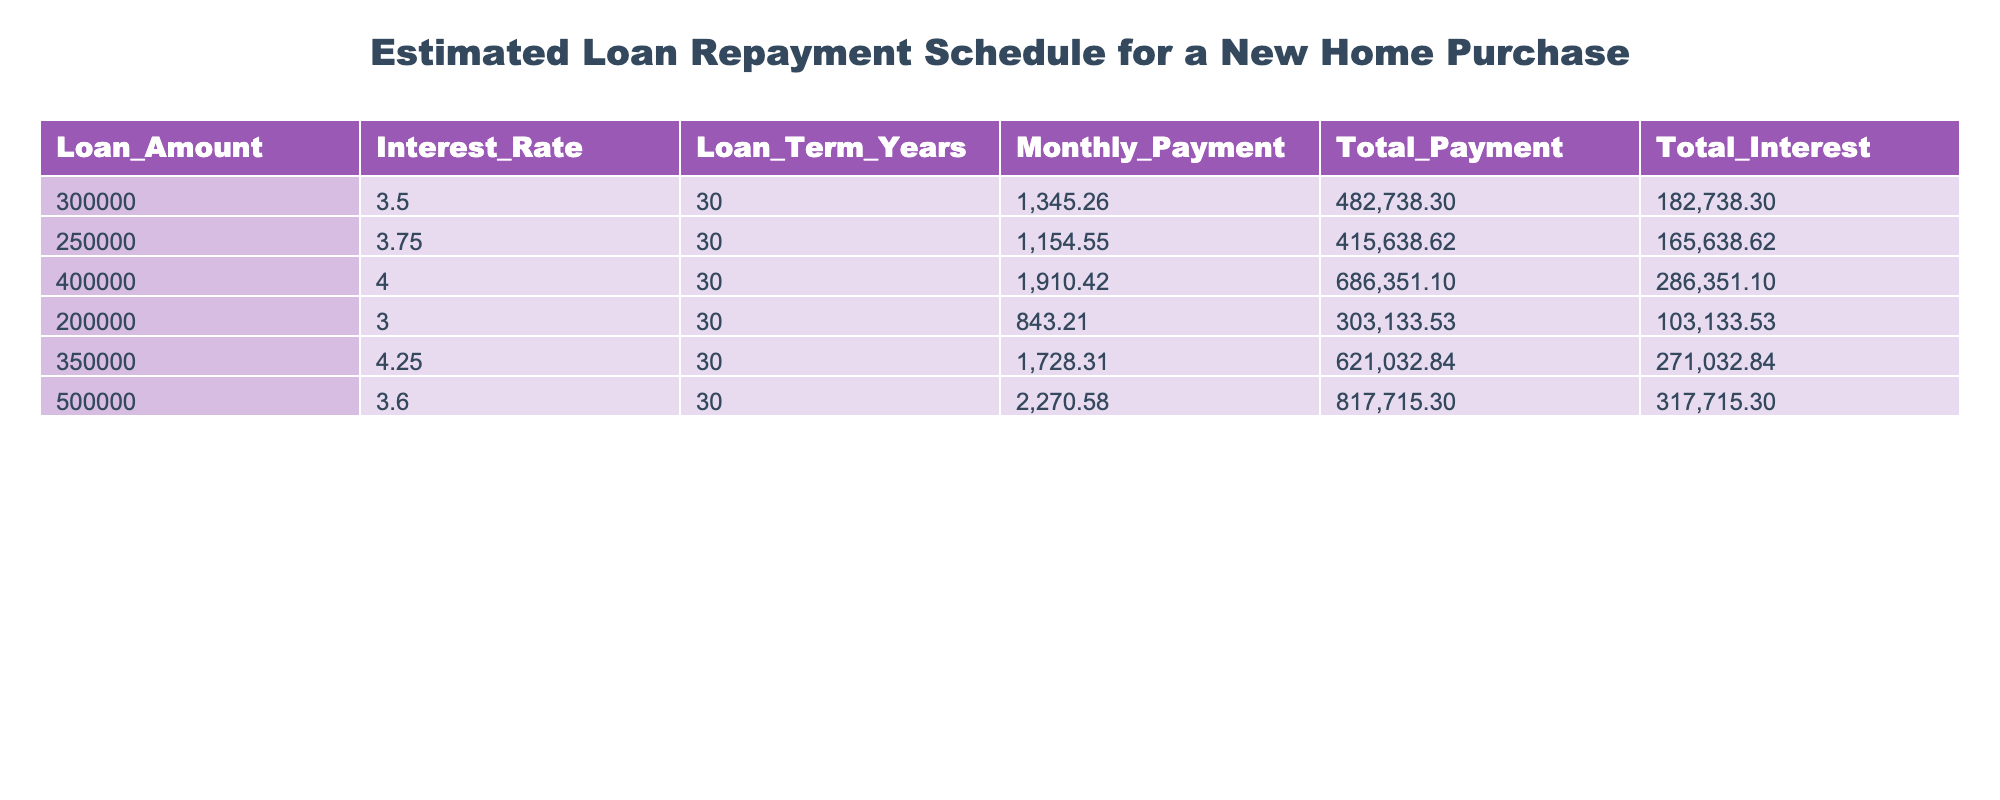What is the loan amount for the highest monthly payment? The table lists multiple loan amounts and their corresponding monthly payments. The maximum monthly payment is 2270.58, which corresponds to a loan amount of 500000.
Answer: 500000 What is the total interest for the loan amount of 250000? Referring to the table, the total interest amount for a loan of 250000 is listed as 165638.62.
Answer: 165638.62 What is the difference in total payment between the $350,000 and $200,000 loans? The total payment for the $350,000 loan is 621032.84 and for the $200,000 loan is 303133.53. Calculating the difference: 621032.84 - 303133.53 = 317899.31.
Answer: 317899.31 Which loan amount has the lowest total interest? The total interest amounts are 182738.30, 165638.62, 286351.10, 103133.53, 271032.84, and 317715.30. The lowest among these is 103133.53, which corresponds to the loan amount of 200000.
Answer: 200000 Is the monthly payment for a $500,000 loan greater than $1500? The monthly payment for the $500,000 loan is 2270.58, which is indeed greater than 1500.
Answer: Yes What is the average monthly payment for the loans listed? The monthly payments are 1345.26, 1154.55, 1910.42, 843.21, 1728.31, and 2270.58. Summing these: 1345.26 + 1154.55 + 1910.42 + 843.21 + 1728.31 + 2270.58 = 10352.33. There are 6 loans, so the average is 10352.33 / 6 ≈ 1725.39.
Answer: 1725.39 